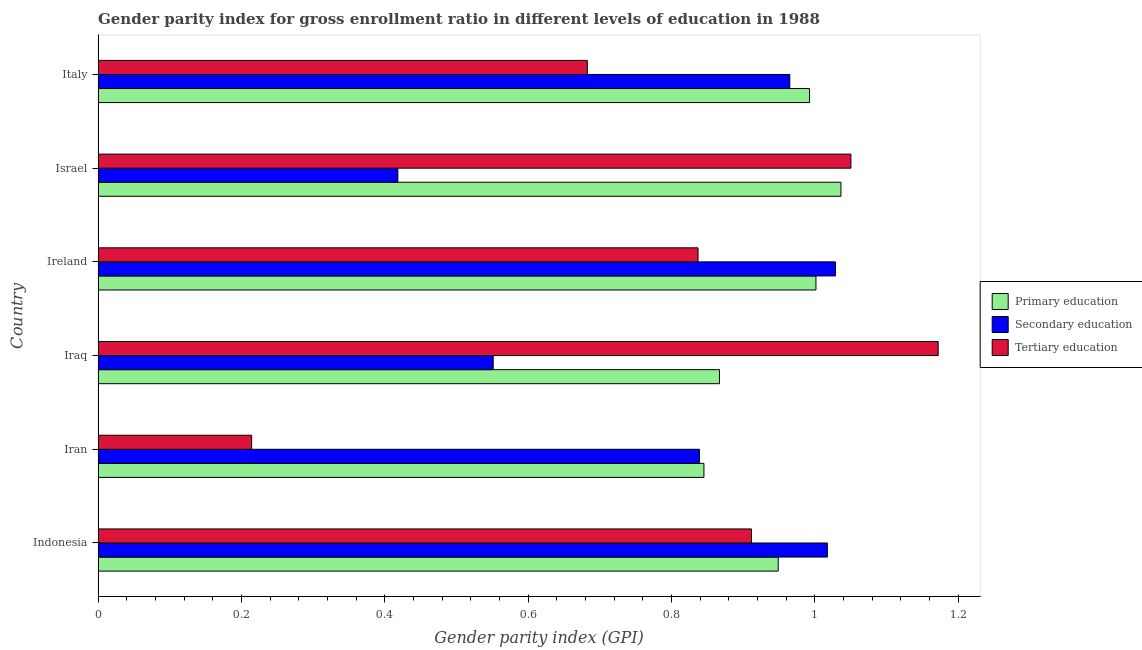How many groups of bars are there?
Your response must be concise. 6. How many bars are there on the 1st tick from the top?
Make the answer very short. 3. What is the label of the 4th group of bars from the top?
Offer a terse response. Iraq. What is the gender parity index in primary education in Iran?
Keep it short and to the point. 0.85. Across all countries, what is the maximum gender parity index in primary education?
Provide a short and direct response. 1.04. Across all countries, what is the minimum gender parity index in primary education?
Offer a very short reply. 0.85. In which country was the gender parity index in tertiary education minimum?
Your answer should be compact. Iran. What is the total gender parity index in tertiary education in the graph?
Offer a terse response. 4.87. What is the difference between the gender parity index in primary education in Israel and that in Italy?
Give a very brief answer. 0.04. What is the difference between the gender parity index in tertiary education in Ireland and the gender parity index in secondary education in Iraq?
Ensure brevity in your answer.  0.29. What is the average gender parity index in tertiary education per country?
Ensure brevity in your answer.  0.81. What is the difference between the gender parity index in tertiary education and gender parity index in secondary education in Ireland?
Give a very brief answer. -0.19. In how many countries, is the gender parity index in primary education greater than 1.16 ?
Your answer should be very brief. 0. What is the ratio of the gender parity index in secondary education in Indonesia to that in Italy?
Your answer should be compact. 1.05. Is the gender parity index in secondary education in Indonesia less than that in Iran?
Offer a terse response. No. What is the difference between the highest and the second highest gender parity index in primary education?
Make the answer very short. 0.04. What is the difference between the highest and the lowest gender parity index in secondary education?
Your answer should be very brief. 0.61. In how many countries, is the gender parity index in tertiary education greater than the average gender parity index in tertiary education taken over all countries?
Give a very brief answer. 4. What does the 2nd bar from the top in Italy represents?
Offer a very short reply. Secondary education. What does the 2nd bar from the bottom in Iran represents?
Your response must be concise. Secondary education. What is the difference between two consecutive major ticks on the X-axis?
Your response must be concise. 0.2. Are the values on the major ticks of X-axis written in scientific E-notation?
Your response must be concise. No. Does the graph contain any zero values?
Your response must be concise. No. How many legend labels are there?
Your response must be concise. 3. What is the title of the graph?
Give a very brief answer. Gender parity index for gross enrollment ratio in different levels of education in 1988. What is the label or title of the X-axis?
Your response must be concise. Gender parity index (GPI). What is the label or title of the Y-axis?
Ensure brevity in your answer.  Country. What is the Gender parity index (GPI) in Primary education in Indonesia?
Keep it short and to the point. 0.95. What is the Gender parity index (GPI) of Secondary education in Indonesia?
Provide a succinct answer. 1.02. What is the Gender parity index (GPI) in Tertiary education in Indonesia?
Give a very brief answer. 0.91. What is the Gender parity index (GPI) in Primary education in Iran?
Give a very brief answer. 0.85. What is the Gender parity index (GPI) of Secondary education in Iran?
Provide a short and direct response. 0.84. What is the Gender parity index (GPI) in Tertiary education in Iran?
Your response must be concise. 0.21. What is the Gender parity index (GPI) of Primary education in Iraq?
Your answer should be compact. 0.87. What is the Gender parity index (GPI) in Secondary education in Iraq?
Keep it short and to the point. 0.55. What is the Gender parity index (GPI) of Tertiary education in Iraq?
Make the answer very short. 1.17. What is the Gender parity index (GPI) in Primary education in Ireland?
Make the answer very short. 1. What is the Gender parity index (GPI) in Secondary education in Ireland?
Provide a short and direct response. 1.03. What is the Gender parity index (GPI) in Tertiary education in Ireland?
Your response must be concise. 0.84. What is the Gender parity index (GPI) of Primary education in Israel?
Your answer should be compact. 1.04. What is the Gender parity index (GPI) in Secondary education in Israel?
Your response must be concise. 0.42. What is the Gender parity index (GPI) of Tertiary education in Israel?
Provide a short and direct response. 1.05. What is the Gender parity index (GPI) in Primary education in Italy?
Your response must be concise. 0.99. What is the Gender parity index (GPI) of Secondary education in Italy?
Offer a very short reply. 0.97. What is the Gender parity index (GPI) of Tertiary education in Italy?
Your response must be concise. 0.68. Across all countries, what is the maximum Gender parity index (GPI) in Primary education?
Your answer should be compact. 1.04. Across all countries, what is the maximum Gender parity index (GPI) in Secondary education?
Provide a short and direct response. 1.03. Across all countries, what is the maximum Gender parity index (GPI) in Tertiary education?
Give a very brief answer. 1.17. Across all countries, what is the minimum Gender parity index (GPI) of Primary education?
Provide a succinct answer. 0.85. Across all countries, what is the minimum Gender parity index (GPI) of Secondary education?
Make the answer very short. 0.42. Across all countries, what is the minimum Gender parity index (GPI) of Tertiary education?
Your answer should be compact. 0.21. What is the total Gender parity index (GPI) of Primary education in the graph?
Give a very brief answer. 5.69. What is the total Gender parity index (GPI) in Secondary education in the graph?
Offer a very short reply. 4.82. What is the total Gender parity index (GPI) of Tertiary education in the graph?
Provide a short and direct response. 4.87. What is the difference between the Gender parity index (GPI) in Primary education in Indonesia and that in Iran?
Provide a succinct answer. 0.1. What is the difference between the Gender parity index (GPI) of Secondary education in Indonesia and that in Iran?
Ensure brevity in your answer.  0.18. What is the difference between the Gender parity index (GPI) in Tertiary education in Indonesia and that in Iran?
Make the answer very short. 0.7. What is the difference between the Gender parity index (GPI) of Primary education in Indonesia and that in Iraq?
Your response must be concise. 0.08. What is the difference between the Gender parity index (GPI) in Secondary education in Indonesia and that in Iraq?
Your answer should be very brief. 0.47. What is the difference between the Gender parity index (GPI) in Tertiary education in Indonesia and that in Iraq?
Your response must be concise. -0.26. What is the difference between the Gender parity index (GPI) of Primary education in Indonesia and that in Ireland?
Your answer should be compact. -0.05. What is the difference between the Gender parity index (GPI) in Secondary education in Indonesia and that in Ireland?
Provide a short and direct response. -0.01. What is the difference between the Gender parity index (GPI) in Tertiary education in Indonesia and that in Ireland?
Your answer should be compact. 0.07. What is the difference between the Gender parity index (GPI) in Primary education in Indonesia and that in Israel?
Make the answer very short. -0.09. What is the difference between the Gender parity index (GPI) of Secondary education in Indonesia and that in Israel?
Provide a succinct answer. 0.6. What is the difference between the Gender parity index (GPI) in Tertiary education in Indonesia and that in Israel?
Your answer should be compact. -0.14. What is the difference between the Gender parity index (GPI) of Primary education in Indonesia and that in Italy?
Give a very brief answer. -0.04. What is the difference between the Gender parity index (GPI) of Secondary education in Indonesia and that in Italy?
Your response must be concise. 0.05. What is the difference between the Gender parity index (GPI) of Tertiary education in Indonesia and that in Italy?
Offer a very short reply. 0.23. What is the difference between the Gender parity index (GPI) in Primary education in Iran and that in Iraq?
Your response must be concise. -0.02. What is the difference between the Gender parity index (GPI) of Secondary education in Iran and that in Iraq?
Offer a terse response. 0.29. What is the difference between the Gender parity index (GPI) in Tertiary education in Iran and that in Iraq?
Make the answer very short. -0.96. What is the difference between the Gender parity index (GPI) in Primary education in Iran and that in Ireland?
Your response must be concise. -0.16. What is the difference between the Gender parity index (GPI) of Secondary education in Iran and that in Ireland?
Keep it short and to the point. -0.19. What is the difference between the Gender parity index (GPI) in Tertiary education in Iran and that in Ireland?
Offer a very short reply. -0.62. What is the difference between the Gender parity index (GPI) of Primary education in Iran and that in Israel?
Make the answer very short. -0.19. What is the difference between the Gender parity index (GPI) in Secondary education in Iran and that in Israel?
Offer a terse response. 0.42. What is the difference between the Gender parity index (GPI) in Tertiary education in Iran and that in Israel?
Ensure brevity in your answer.  -0.84. What is the difference between the Gender parity index (GPI) of Primary education in Iran and that in Italy?
Make the answer very short. -0.15. What is the difference between the Gender parity index (GPI) of Secondary education in Iran and that in Italy?
Provide a succinct answer. -0.13. What is the difference between the Gender parity index (GPI) of Tertiary education in Iran and that in Italy?
Provide a succinct answer. -0.47. What is the difference between the Gender parity index (GPI) in Primary education in Iraq and that in Ireland?
Your answer should be compact. -0.13. What is the difference between the Gender parity index (GPI) in Secondary education in Iraq and that in Ireland?
Offer a very short reply. -0.48. What is the difference between the Gender parity index (GPI) of Tertiary education in Iraq and that in Ireland?
Give a very brief answer. 0.34. What is the difference between the Gender parity index (GPI) of Primary education in Iraq and that in Israel?
Keep it short and to the point. -0.17. What is the difference between the Gender parity index (GPI) of Secondary education in Iraq and that in Israel?
Keep it short and to the point. 0.13. What is the difference between the Gender parity index (GPI) of Tertiary education in Iraq and that in Israel?
Offer a very short reply. 0.12. What is the difference between the Gender parity index (GPI) in Primary education in Iraq and that in Italy?
Provide a succinct answer. -0.13. What is the difference between the Gender parity index (GPI) of Secondary education in Iraq and that in Italy?
Offer a terse response. -0.41. What is the difference between the Gender parity index (GPI) in Tertiary education in Iraq and that in Italy?
Keep it short and to the point. 0.49. What is the difference between the Gender parity index (GPI) of Primary education in Ireland and that in Israel?
Your response must be concise. -0.03. What is the difference between the Gender parity index (GPI) of Secondary education in Ireland and that in Israel?
Your response must be concise. 0.61. What is the difference between the Gender parity index (GPI) in Tertiary education in Ireland and that in Israel?
Ensure brevity in your answer.  -0.21. What is the difference between the Gender parity index (GPI) in Primary education in Ireland and that in Italy?
Provide a succinct answer. 0.01. What is the difference between the Gender parity index (GPI) of Secondary education in Ireland and that in Italy?
Keep it short and to the point. 0.06. What is the difference between the Gender parity index (GPI) of Tertiary education in Ireland and that in Italy?
Keep it short and to the point. 0.15. What is the difference between the Gender parity index (GPI) in Primary education in Israel and that in Italy?
Your answer should be very brief. 0.04. What is the difference between the Gender parity index (GPI) of Secondary education in Israel and that in Italy?
Your answer should be compact. -0.55. What is the difference between the Gender parity index (GPI) in Tertiary education in Israel and that in Italy?
Give a very brief answer. 0.37. What is the difference between the Gender parity index (GPI) in Primary education in Indonesia and the Gender parity index (GPI) in Secondary education in Iran?
Ensure brevity in your answer.  0.11. What is the difference between the Gender parity index (GPI) of Primary education in Indonesia and the Gender parity index (GPI) of Tertiary education in Iran?
Offer a very short reply. 0.73. What is the difference between the Gender parity index (GPI) in Secondary education in Indonesia and the Gender parity index (GPI) in Tertiary education in Iran?
Provide a short and direct response. 0.8. What is the difference between the Gender parity index (GPI) of Primary education in Indonesia and the Gender parity index (GPI) of Secondary education in Iraq?
Make the answer very short. 0.4. What is the difference between the Gender parity index (GPI) in Primary education in Indonesia and the Gender parity index (GPI) in Tertiary education in Iraq?
Offer a very short reply. -0.22. What is the difference between the Gender parity index (GPI) in Secondary education in Indonesia and the Gender parity index (GPI) in Tertiary education in Iraq?
Your answer should be very brief. -0.15. What is the difference between the Gender parity index (GPI) in Primary education in Indonesia and the Gender parity index (GPI) in Secondary education in Ireland?
Provide a short and direct response. -0.08. What is the difference between the Gender parity index (GPI) in Primary education in Indonesia and the Gender parity index (GPI) in Tertiary education in Ireland?
Make the answer very short. 0.11. What is the difference between the Gender parity index (GPI) in Secondary education in Indonesia and the Gender parity index (GPI) in Tertiary education in Ireland?
Your answer should be compact. 0.18. What is the difference between the Gender parity index (GPI) of Primary education in Indonesia and the Gender parity index (GPI) of Secondary education in Israel?
Provide a short and direct response. 0.53. What is the difference between the Gender parity index (GPI) in Primary education in Indonesia and the Gender parity index (GPI) in Tertiary education in Israel?
Provide a short and direct response. -0.1. What is the difference between the Gender parity index (GPI) in Secondary education in Indonesia and the Gender parity index (GPI) in Tertiary education in Israel?
Provide a short and direct response. -0.03. What is the difference between the Gender parity index (GPI) of Primary education in Indonesia and the Gender parity index (GPI) of Secondary education in Italy?
Your answer should be very brief. -0.02. What is the difference between the Gender parity index (GPI) in Primary education in Indonesia and the Gender parity index (GPI) in Tertiary education in Italy?
Provide a short and direct response. 0.27. What is the difference between the Gender parity index (GPI) in Secondary education in Indonesia and the Gender parity index (GPI) in Tertiary education in Italy?
Keep it short and to the point. 0.34. What is the difference between the Gender parity index (GPI) of Primary education in Iran and the Gender parity index (GPI) of Secondary education in Iraq?
Provide a succinct answer. 0.29. What is the difference between the Gender parity index (GPI) in Primary education in Iran and the Gender parity index (GPI) in Tertiary education in Iraq?
Ensure brevity in your answer.  -0.33. What is the difference between the Gender parity index (GPI) of Secondary education in Iran and the Gender parity index (GPI) of Tertiary education in Iraq?
Your answer should be very brief. -0.33. What is the difference between the Gender parity index (GPI) of Primary education in Iran and the Gender parity index (GPI) of Secondary education in Ireland?
Keep it short and to the point. -0.18. What is the difference between the Gender parity index (GPI) of Primary education in Iran and the Gender parity index (GPI) of Tertiary education in Ireland?
Your answer should be very brief. 0.01. What is the difference between the Gender parity index (GPI) of Secondary education in Iran and the Gender parity index (GPI) of Tertiary education in Ireland?
Your response must be concise. 0. What is the difference between the Gender parity index (GPI) in Primary education in Iran and the Gender parity index (GPI) in Secondary education in Israel?
Your answer should be compact. 0.43. What is the difference between the Gender parity index (GPI) in Primary education in Iran and the Gender parity index (GPI) in Tertiary education in Israel?
Offer a very short reply. -0.21. What is the difference between the Gender parity index (GPI) in Secondary education in Iran and the Gender parity index (GPI) in Tertiary education in Israel?
Keep it short and to the point. -0.21. What is the difference between the Gender parity index (GPI) in Primary education in Iran and the Gender parity index (GPI) in Secondary education in Italy?
Provide a succinct answer. -0.12. What is the difference between the Gender parity index (GPI) in Primary education in Iran and the Gender parity index (GPI) in Tertiary education in Italy?
Provide a short and direct response. 0.16. What is the difference between the Gender parity index (GPI) of Secondary education in Iran and the Gender parity index (GPI) of Tertiary education in Italy?
Offer a very short reply. 0.16. What is the difference between the Gender parity index (GPI) in Primary education in Iraq and the Gender parity index (GPI) in Secondary education in Ireland?
Your response must be concise. -0.16. What is the difference between the Gender parity index (GPI) of Primary education in Iraq and the Gender parity index (GPI) of Tertiary education in Ireland?
Offer a very short reply. 0.03. What is the difference between the Gender parity index (GPI) of Secondary education in Iraq and the Gender parity index (GPI) of Tertiary education in Ireland?
Make the answer very short. -0.29. What is the difference between the Gender parity index (GPI) in Primary education in Iraq and the Gender parity index (GPI) in Secondary education in Israel?
Your response must be concise. 0.45. What is the difference between the Gender parity index (GPI) in Primary education in Iraq and the Gender parity index (GPI) in Tertiary education in Israel?
Provide a short and direct response. -0.18. What is the difference between the Gender parity index (GPI) in Secondary education in Iraq and the Gender parity index (GPI) in Tertiary education in Israel?
Provide a short and direct response. -0.5. What is the difference between the Gender parity index (GPI) in Primary education in Iraq and the Gender parity index (GPI) in Secondary education in Italy?
Make the answer very short. -0.1. What is the difference between the Gender parity index (GPI) in Primary education in Iraq and the Gender parity index (GPI) in Tertiary education in Italy?
Ensure brevity in your answer.  0.18. What is the difference between the Gender parity index (GPI) in Secondary education in Iraq and the Gender parity index (GPI) in Tertiary education in Italy?
Provide a succinct answer. -0.13. What is the difference between the Gender parity index (GPI) in Primary education in Ireland and the Gender parity index (GPI) in Secondary education in Israel?
Your answer should be compact. 0.58. What is the difference between the Gender parity index (GPI) in Primary education in Ireland and the Gender parity index (GPI) in Tertiary education in Israel?
Your response must be concise. -0.05. What is the difference between the Gender parity index (GPI) in Secondary education in Ireland and the Gender parity index (GPI) in Tertiary education in Israel?
Give a very brief answer. -0.02. What is the difference between the Gender parity index (GPI) of Primary education in Ireland and the Gender parity index (GPI) of Secondary education in Italy?
Give a very brief answer. 0.04. What is the difference between the Gender parity index (GPI) of Primary education in Ireland and the Gender parity index (GPI) of Tertiary education in Italy?
Keep it short and to the point. 0.32. What is the difference between the Gender parity index (GPI) of Secondary education in Ireland and the Gender parity index (GPI) of Tertiary education in Italy?
Ensure brevity in your answer.  0.35. What is the difference between the Gender parity index (GPI) of Primary education in Israel and the Gender parity index (GPI) of Secondary education in Italy?
Your response must be concise. 0.07. What is the difference between the Gender parity index (GPI) of Primary education in Israel and the Gender parity index (GPI) of Tertiary education in Italy?
Offer a very short reply. 0.35. What is the difference between the Gender parity index (GPI) in Secondary education in Israel and the Gender parity index (GPI) in Tertiary education in Italy?
Offer a terse response. -0.26. What is the average Gender parity index (GPI) of Primary education per country?
Provide a short and direct response. 0.95. What is the average Gender parity index (GPI) of Secondary education per country?
Ensure brevity in your answer.  0.8. What is the average Gender parity index (GPI) in Tertiary education per country?
Your response must be concise. 0.81. What is the difference between the Gender parity index (GPI) of Primary education and Gender parity index (GPI) of Secondary education in Indonesia?
Your answer should be very brief. -0.07. What is the difference between the Gender parity index (GPI) of Primary education and Gender parity index (GPI) of Tertiary education in Indonesia?
Ensure brevity in your answer.  0.04. What is the difference between the Gender parity index (GPI) of Secondary education and Gender parity index (GPI) of Tertiary education in Indonesia?
Offer a terse response. 0.11. What is the difference between the Gender parity index (GPI) of Primary education and Gender parity index (GPI) of Secondary education in Iran?
Offer a terse response. 0.01. What is the difference between the Gender parity index (GPI) in Primary education and Gender parity index (GPI) in Tertiary education in Iran?
Your answer should be very brief. 0.63. What is the difference between the Gender parity index (GPI) in Secondary education and Gender parity index (GPI) in Tertiary education in Iran?
Provide a succinct answer. 0.62. What is the difference between the Gender parity index (GPI) in Primary education and Gender parity index (GPI) in Secondary education in Iraq?
Your response must be concise. 0.32. What is the difference between the Gender parity index (GPI) in Primary education and Gender parity index (GPI) in Tertiary education in Iraq?
Ensure brevity in your answer.  -0.31. What is the difference between the Gender parity index (GPI) of Secondary education and Gender parity index (GPI) of Tertiary education in Iraq?
Your answer should be compact. -0.62. What is the difference between the Gender parity index (GPI) in Primary education and Gender parity index (GPI) in Secondary education in Ireland?
Make the answer very short. -0.03. What is the difference between the Gender parity index (GPI) of Primary education and Gender parity index (GPI) of Tertiary education in Ireland?
Offer a terse response. 0.16. What is the difference between the Gender parity index (GPI) in Secondary education and Gender parity index (GPI) in Tertiary education in Ireland?
Provide a succinct answer. 0.19. What is the difference between the Gender parity index (GPI) in Primary education and Gender parity index (GPI) in Secondary education in Israel?
Offer a terse response. 0.62. What is the difference between the Gender parity index (GPI) of Primary education and Gender parity index (GPI) of Tertiary education in Israel?
Offer a terse response. -0.01. What is the difference between the Gender parity index (GPI) in Secondary education and Gender parity index (GPI) in Tertiary education in Israel?
Your response must be concise. -0.63. What is the difference between the Gender parity index (GPI) of Primary education and Gender parity index (GPI) of Secondary education in Italy?
Keep it short and to the point. 0.03. What is the difference between the Gender parity index (GPI) in Primary education and Gender parity index (GPI) in Tertiary education in Italy?
Provide a succinct answer. 0.31. What is the difference between the Gender parity index (GPI) of Secondary education and Gender parity index (GPI) of Tertiary education in Italy?
Make the answer very short. 0.28. What is the ratio of the Gender parity index (GPI) in Primary education in Indonesia to that in Iran?
Keep it short and to the point. 1.12. What is the ratio of the Gender parity index (GPI) of Secondary education in Indonesia to that in Iran?
Provide a short and direct response. 1.21. What is the ratio of the Gender parity index (GPI) of Tertiary education in Indonesia to that in Iran?
Offer a very short reply. 4.26. What is the ratio of the Gender parity index (GPI) of Primary education in Indonesia to that in Iraq?
Your response must be concise. 1.09. What is the ratio of the Gender parity index (GPI) in Secondary education in Indonesia to that in Iraq?
Your answer should be compact. 1.85. What is the ratio of the Gender parity index (GPI) in Tertiary education in Indonesia to that in Iraq?
Your answer should be compact. 0.78. What is the ratio of the Gender parity index (GPI) of Tertiary education in Indonesia to that in Ireland?
Ensure brevity in your answer.  1.09. What is the ratio of the Gender parity index (GPI) of Primary education in Indonesia to that in Israel?
Your response must be concise. 0.92. What is the ratio of the Gender parity index (GPI) of Secondary education in Indonesia to that in Israel?
Make the answer very short. 2.43. What is the ratio of the Gender parity index (GPI) of Tertiary education in Indonesia to that in Israel?
Your answer should be very brief. 0.87. What is the ratio of the Gender parity index (GPI) of Primary education in Indonesia to that in Italy?
Your response must be concise. 0.96. What is the ratio of the Gender parity index (GPI) of Secondary education in Indonesia to that in Italy?
Your answer should be compact. 1.05. What is the ratio of the Gender parity index (GPI) of Tertiary education in Indonesia to that in Italy?
Make the answer very short. 1.34. What is the ratio of the Gender parity index (GPI) in Primary education in Iran to that in Iraq?
Offer a very short reply. 0.97. What is the ratio of the Gender parity index (GPI) in Secondary education in Iran to that in Iraq?
Make the answer very short. 1.52. What is the ratio of the Gender parity index (GPI) in Tertiary education in Iran to that in Iraq?
Offer a terse response. 0.18. What is the ratio of the Gender parity index (GPI) of Primary education in Iran to that in Ireland?
Provide a short and direct response. 0.84. What is the ratio of the Gender parity index (GPI) in Secondary education in Iran to that in Ireland?
Your response must be concise. 0.82. What is the ratio of the Gender parity index (GPI) in Tertiary education in Iran to that in Ireland?
Give a very brief answer. 0.26. What is the ratio of the Gender parity index (GPI) of Primary education in Iran to that in Israel?
Offer a terse response. 0.82. What is the ratio of the Gender parity index (GPI) of Secondary education in Iran to that in Israel?
Your answer should be very brief. 2.01. What is the ratio of the Gender parity index (GPI) of Tertiary education in Iran to that in Israel?
Give a very brief answer. 0.2. What is the ratio of the Gender parity index (GPI) of Primary education in Iran to that in Italy?
Ensure brevity in your answer.  0.85. What is the ratio of the Gender parity index (GPI) of Secondary education in Iran to that in Italy?
Your answer should be very brief. 0.87. What is the ratio of the Gender parity index (GPI) in Tertiary education in Iran to that in Italy?
Provide a short and direct response. 0.31. What is the ratio of the Gender parity index (GPI) of Primary education in Iraq to that in Ireland?
Give a very brief answer. 0.87. What is the ratio of the Gender parity index (GPI) of Secondary education in Iraq to that in Ireland?
Keep it short and to the point. 0.54. What is the ratio of the Gender parity index (GPI) of Tertiary education in Iraq to that in Ireland?
Keep it short and to the point. 1.4. What is the ratio of the Gender parity index (GPI) of Primary education in Iraq to that in Israel?
Offer a very short reply. 0.84. What is the ratio of the Gender parity index (GPI) of Secondary education in Iraq to that in Israel?
Give a very brief answer. 1.32. What is the ratio of the Gender parity index (GPI) of Tertiary education in Iraq to that in Israel?
Your answer should be compact. 1.12. What is the ratio of the Gender parity index (GPI) in Primary education in Iraq to that in Italy?
Give a very brief answer. 0.87. What is the ratio of the Gender parity index (GPI) in Secondary education in Iraq to that in Italy?
Your answer should be very brief. 0.57. What is the ratio of the Gender parity index (GPI) in Tertiary education in Iraq to that in Italy?
Provide a succinct answer. 1.72. What is the ratio of the Gender parity index (GPI) in Primary education in Ireland to that in Israel?
Keep it short and to the point. 0.97. What is the ratio of the Gender parity index (GPI) in Secondary education in Ireland to that in Israel?
Your answer should be compact. 2.46. What is the ratio of the Gender parity index (GPI) in Tertiary education in Ireland to that in Israel?
Ensure brevity in your answer.  0.8. What is the ratio of the Gender parity index (GPI) in Secondary education in Ireland to that in Italy?
Your answer should be compact. 1.07. What is the ratio of the Gender parity index (GPI) in Tertiary education in Ireland to that in Italy?
Ensure brevity in your answer.  1.23. What is the ratio of the Gender parity index (GPI) in Primary education in Israel to that in Italy?
Your response must be concise. 1.04. What is the ratio of the Gender parity index (GPI) in Secondary education in Israel to that in Italy?
Provide a short and direct response. 0.43. What is the ratio of the Gender parity index (GPI) of Tertiary education in Israel to that in Italy?
Your answer should be compact. 1.54. What is the difference between the highest and the second highest Gender parity index (GPI) in Primary education?
Provide a short and direct response. 0.03. What is the difference between the highest and the second highest Gender parity index (GPI) of Secondary education?
Offer a very short reply. 0.01. What is the difference between the highest and the second highest Gender parity index (GPI) in Tertiary education?
Your answer should be compact. 0.12. What is the difference between the highest and the lowest Gender parity index (GPI) of Primary education?
Ensure brevity in your answer.  0.19. What is the difference between the highest and the lowest Gender parity index (GPI) of Secondary education?
Give a very brief answer. 0.61. What is the difference between the highest and the lowest Gender parity index (GPI) of Tertiary education?
Make the answer very short. 0.96. 